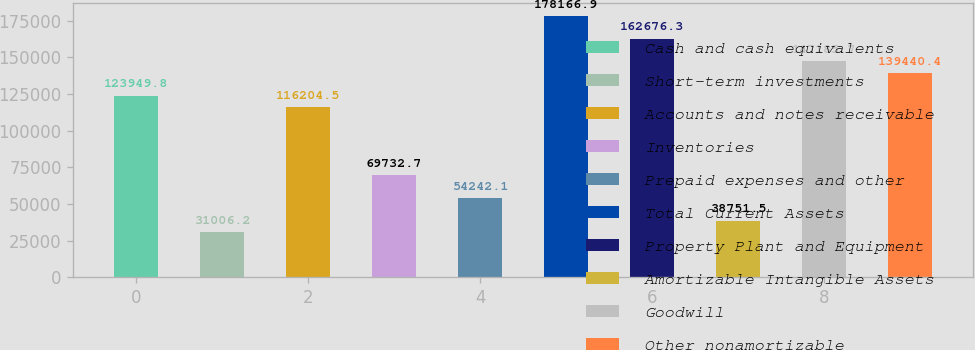<chart> <loc_0><loc_0><loc_500><loc_500><bar_chart><fcel>Cash and cash equivalents<fcel>Short-term investments<fcel>Accounts and notes receivable<fcel>Inventories<fcel>Prepaid expenses and other<fcel>Total Current Assets<fcel>Property Plant and Equipment<fcel>Amortizable Intangible Assets<fcel>Goodwill<fcel>Other nonamortizable<nl><fcel>123950<fcel>31006.2<fcel>116204<fcel>69732.7<fcel>54242.1<fcel>178167<fcel>162676<fcel>38751.5<fcel>147186<fcel>139440<nl></chart> 